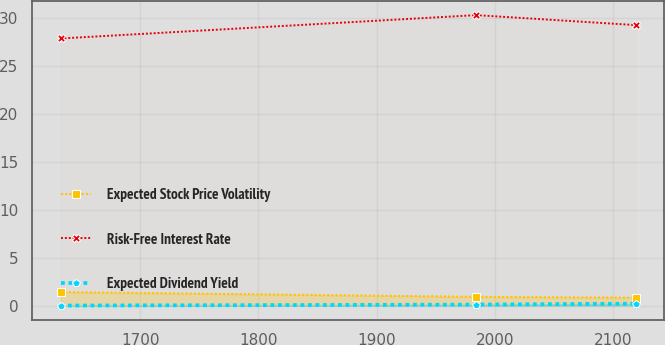<chart> <loc_0><loc_0><loc_500><loc_500><line_chart><ecel><fcel>Expected Stock Price Volatility<fcel>Risk-Free Interest Rate<fcel>Expected Dividend Yield<nl><fcel>1632.46<fcel>1.41<fcel>27.9<fcel>0<nl><fcel>1984.27<fcel>0.91<fcel>30.34<fcel>0.1<nl><fcel>2119.32<fcel>0.82<fcel>29.3<fcel>0.2<nl></chart> 